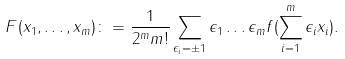<formula> <loc_0><loc_0><loc_500><loc_500>F ( x _ { 1 } , \dots , x _ { m } ) \colon = \frac { 1 } { 2 ^ { m } m ! } \sum _ { \epsilon _ { i } = \pm 1 } \epsilon _ { 1 } \dots \epsilon _ { m } f ( \sum _ { i = 1 } ^ { m } \epsilon _ { i } x _ { i } ) .</formula> 